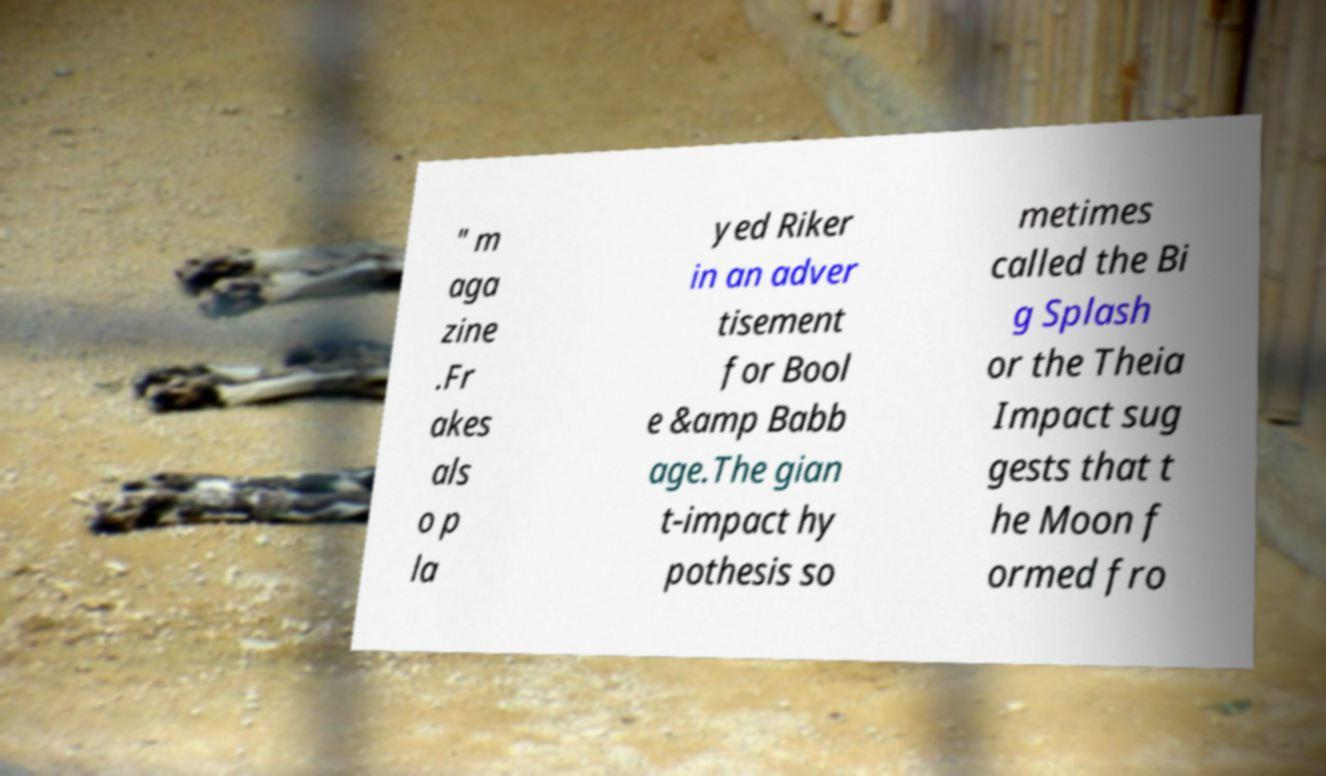I need the written content from this picture converted into text. Can you do that? " m aga zine .Fr akes als o p la yed Riker in an adver tisement for Bool e &amp Babb age.The gian t-impact hy pothesis so metimes called the Bi g Splash or the Theia Impact sug gests that t he Moon f ormed fro 